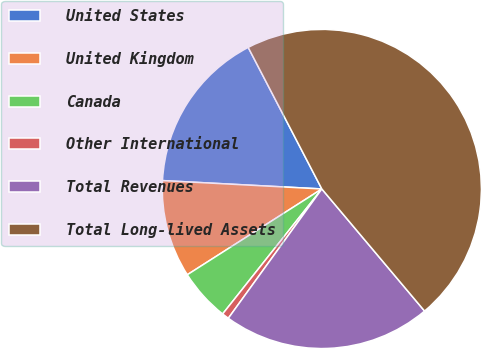<chart> <loc_0><loc_0><loc_500><loc_500><pie_chart><fcel>United States<fcel>United Kingdom<fcel>Canada<fcel>Other International<fcel>Total Revenues<fcel>Total Long-lived Assets<nl><fcel>16.53%<fcel>9.87%<fcel>5.29%<fcel>0.71%<fcel>21.1%<fcel>46.5%<nl></chart> 